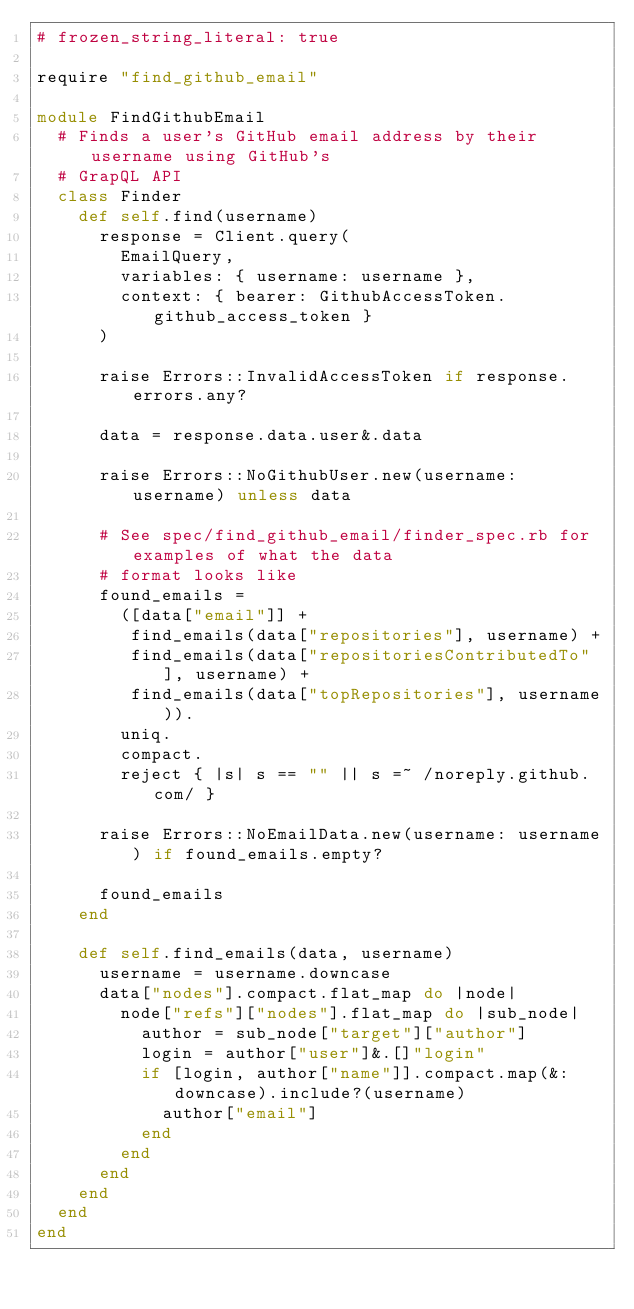<code> <loc_0><loc_0><loc_500><loc_500><_Ruby_># frozen_string_literal: true

require "find_github_email"

module FindGithubEmail
  # Finds a user's GitHub email address by their username using GitHub's
  # GrapQL API
  class Finder
    def self.find(username)
      response = Client.query(
        EmailQuery,
        variables: { username: username },
        context: { bearer: GithubAccessToken.github_access_token }
      )

      raise Errors::InvalidAccessToken if response.errors.any?

      data = response.data.user&.data

      raise Errors::NoGithubUser.new(username: username) unless data

      # See spec/find_github_email/finder_spec.rb for examples of what the data
      # format looks like
      found_emails =
        ([data["email"]] +
         find_emails(data["repositories"], username) +
         find_emails(data["repositoriesContributedTo"], username) +
         find_emails(data["topRepositories"], username)).
        uniq.
        compact.
        reject { |s| s == "" || s =~ /noreply.github.com/ }

      raise Errors::NoEmailData.new(username: username) if found_emails.empty?

      found_emails
    end

    def self.find_emails(data, username)
      username = username.downcase
      data["nodes"].compact.flat_map do |node|
        node["refs"]["nodes"].flat_map do |sub_node|
          author = sub_node["target"]["author"]
          login = author["user"]&.[]"login"
          if [login, author["name"]].compact.map(&:downcase).include?(username)
            author["email"]
          end
        end
      end
    end
  end
end
</code> 